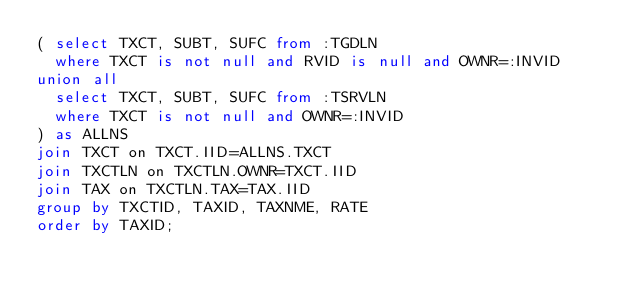Convert code to text. <code><loc_0><loc_0><loc_500><loc_500><_SQL_>( select TXCT, SUBT, SUFC from :TGDLN
  where TXCT is not null and RVID is null and OWNR=:INVID
union all
  select TXCT, SUBT, SUFC from :TSRVLN
  where TXCT is not null and OWNR=:INVID
) as ALLNS
join TXCT on TXCT.IID=ALLNS.TXCT
join TXCTLN on TXCTLN.OWNR=TXCT.IID
join TAX on TXCTLN.TAX=TAX.IID
group by TXCTID, TAXID, TAXNME, RATE
order by TAXID;
</code> 